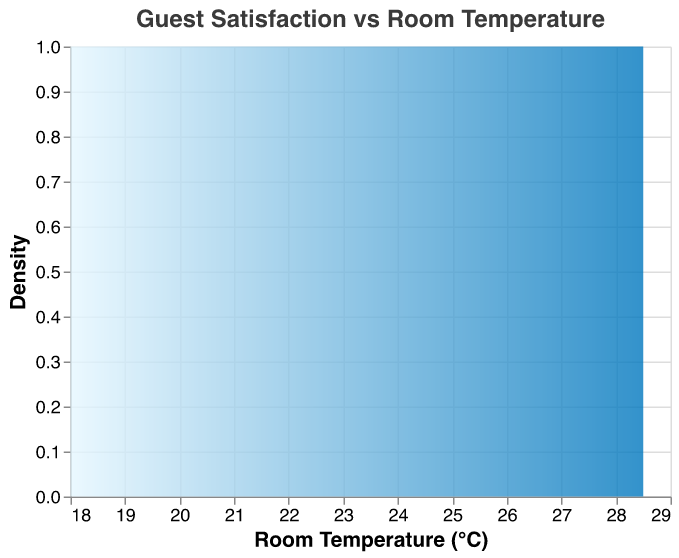What is the title of the plot? The title can be found at the top of the plot. It is usually descriptive of what the plot represents.
Answer: Guest Satisfaction vs Room Temperature What is the range of room temperatures shown in the plot? The x-axis represents room temperature and its range is indicated from the minimum to the maximum values shown along this axis.
Answer: 18°C to 28.5°C What room temperature appears to have the highest density of guest satisfaction scores? By looking at the peak of the density plot, which shows where the values are most concentrated, we can determine the room temperature with the highest density.
Answer: 22°C What happens to guest satisfaction as room temperature increases past 22°C? Observing the trend of the density plot beyond 22°C, we can see how the density decreases, indicating a drop in guest satisfaction scores.
Answer: It decreases Which room temperature range has the lowest density of guest satisfaction scores? Identifying the troughs or lowest points of the density plot can reveal the range with the least density of scores.
Answer: 27.5°C to 28.5°C How does the density of guest satisfaction scores change between 18°C and 21.5°C? By examining the slope and area under the plot line within this temperature range, we can observe if the density increases, decreases, or remains stable.
Answer: It increases Compare the guest satisfaction density at 20.5°C and 25.5°C. Which temperature has a higher density? By locating both temperatures on the x-axis and comparing the height of the density plot at these points, we can determine the higher density.
Answer: 20.5°C Does the density plot suggest an optimal room temperature for guest satisfaction, and if so, what temperature? By analyzing where the density is highest, we can infer the most optimal room temperature for guest satisfaction.
Answer: Yes, at 22°C How does the density plot's color gradient help in interpreting the data? The gradient color from light to dark can visually indicate areas of lower to higher density, helping in quick identification of peaks and troughs in the plot.
Answer: It highlights density variations 